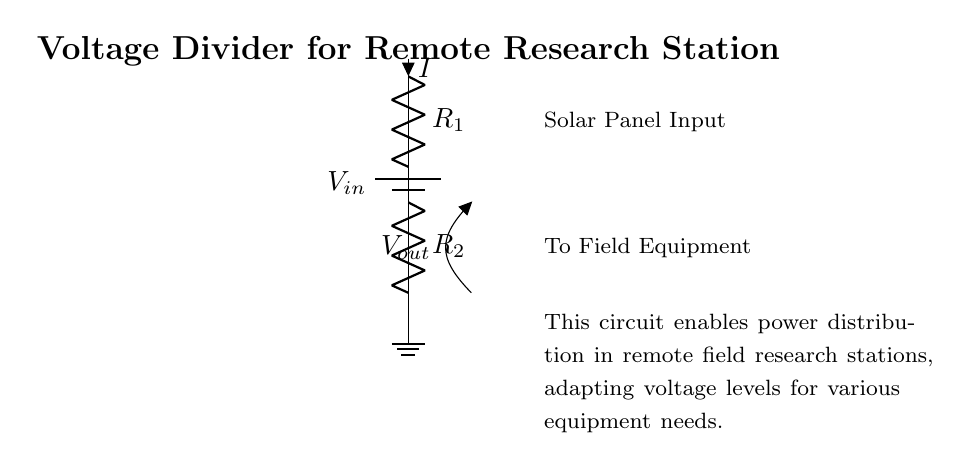What type of circuit is represented? The circuit is a voltage divider circuit, as it divides the input voltage into smaller output voltages using resistors.
Answer: voltage divider What components are used in this circuit? The circuit diagram shows two resistors and a battery as the primary components. The resistors are labeled R1 and R2, and the battery is labeled Vin.
Answer: battery and resistors What is the role of the battery in this circuit? The battery provides the input voltage necessary for the circuit to function, supplying power to the resistors for voltage division.
Answer: power supply What is the output voltage labeled as? It is labeled as Vout, indicating the voltage available across R2 for any connected field equipment.
Answer: Vout How does the current flow in this circuit? Current flows from the positive terminal of the battery through R1, then through R2, and finally returns to the battery's negative terminal, indicating a series connection.
Answer: series What happens to the output voltage if R2 is increased? Increasing R2 will increase the output voltage (Vout) because, in a voltage divider, a higher resistor in the lower position results in a larger proportion of the input voltage.
Answer: Vout increases What is the purpose of this voltage divider circuit in remote research stations? The voltage divider adapts the input voltage to different equipment voltage requirements in remote research stations, making it capable of powering various devices.
Answer: power distribution 